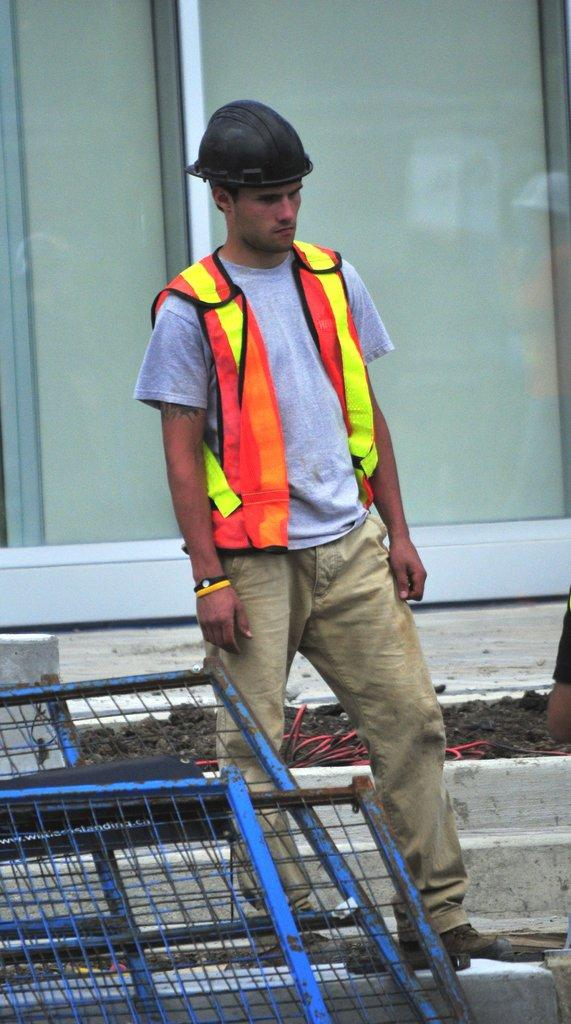What type of structure can be seen in the image? There is a fence in the image. Can you describe the person in the image? There is a man standing in the image. What feature of the fence is visible in the image? There is a door in the image. What type of beast is causing trouble in the image? There is no beast or trouble present in the image; it only features a fence, a man, and a door. 